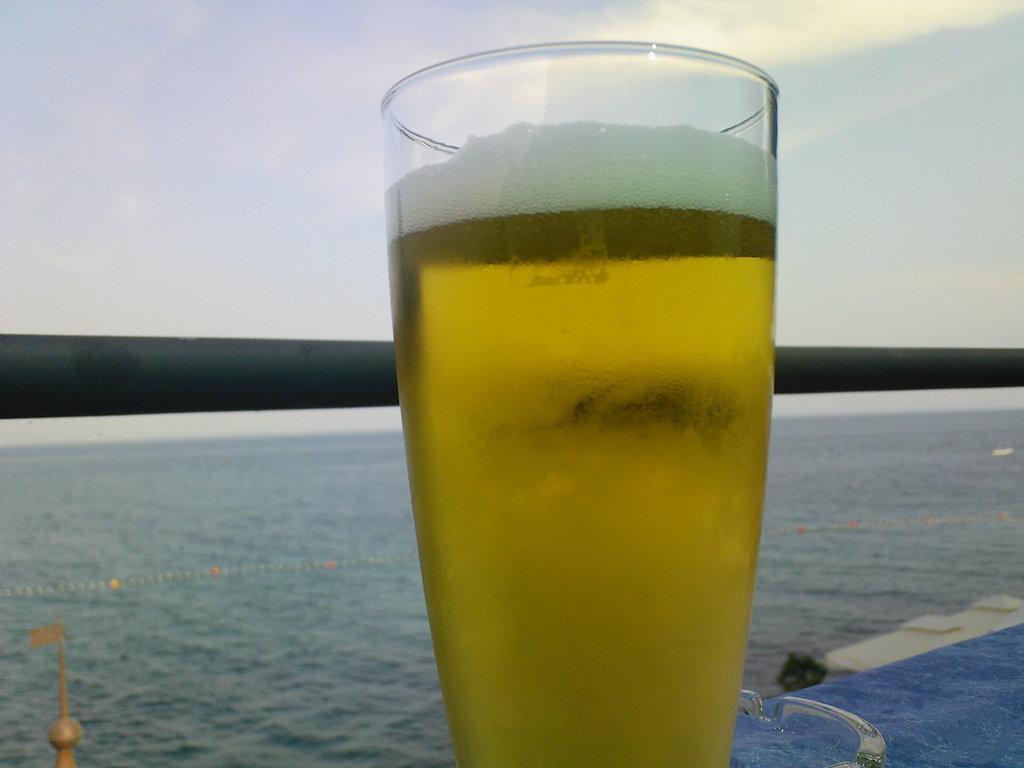Describe this image in one or two sentences. In this picture we can see a glass of drink and a metal rod in the front, in the background there is water, we can see the sky at the top of the picture. 